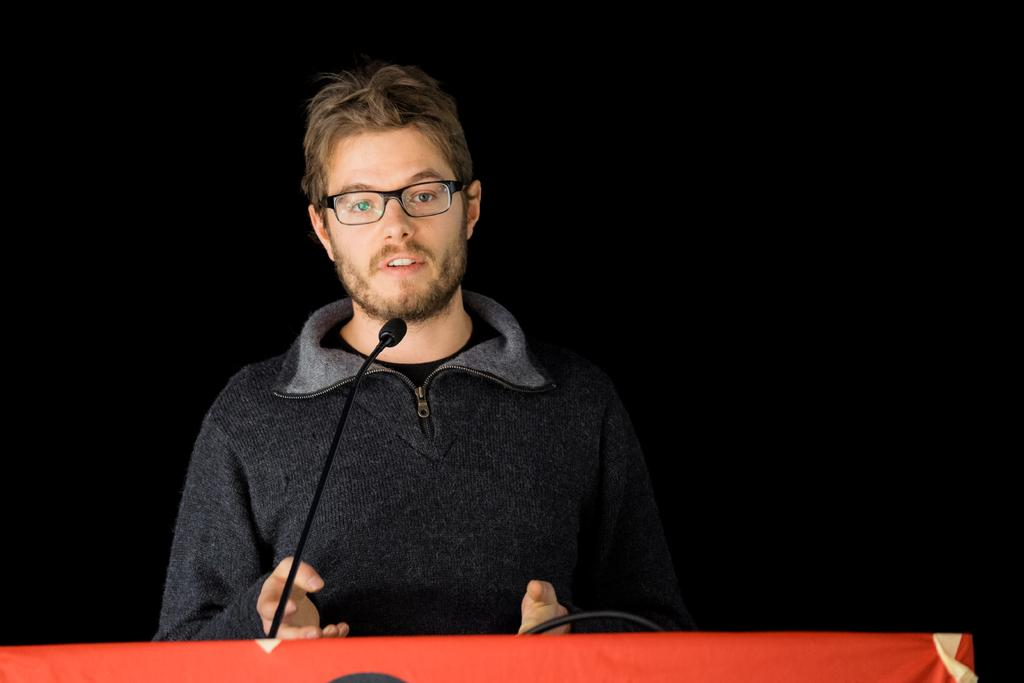What is the main subject of the image? There is a person standing in the image. What object is present near the person? There is a podium in the image. What device is used for amplifying the person's voice? There is a microphone in the image. What color is the background of the image? The background of the image is black. How many wheels are visible on the person in the image? There are no visible wheels on the person in the image, as the person is standing. 